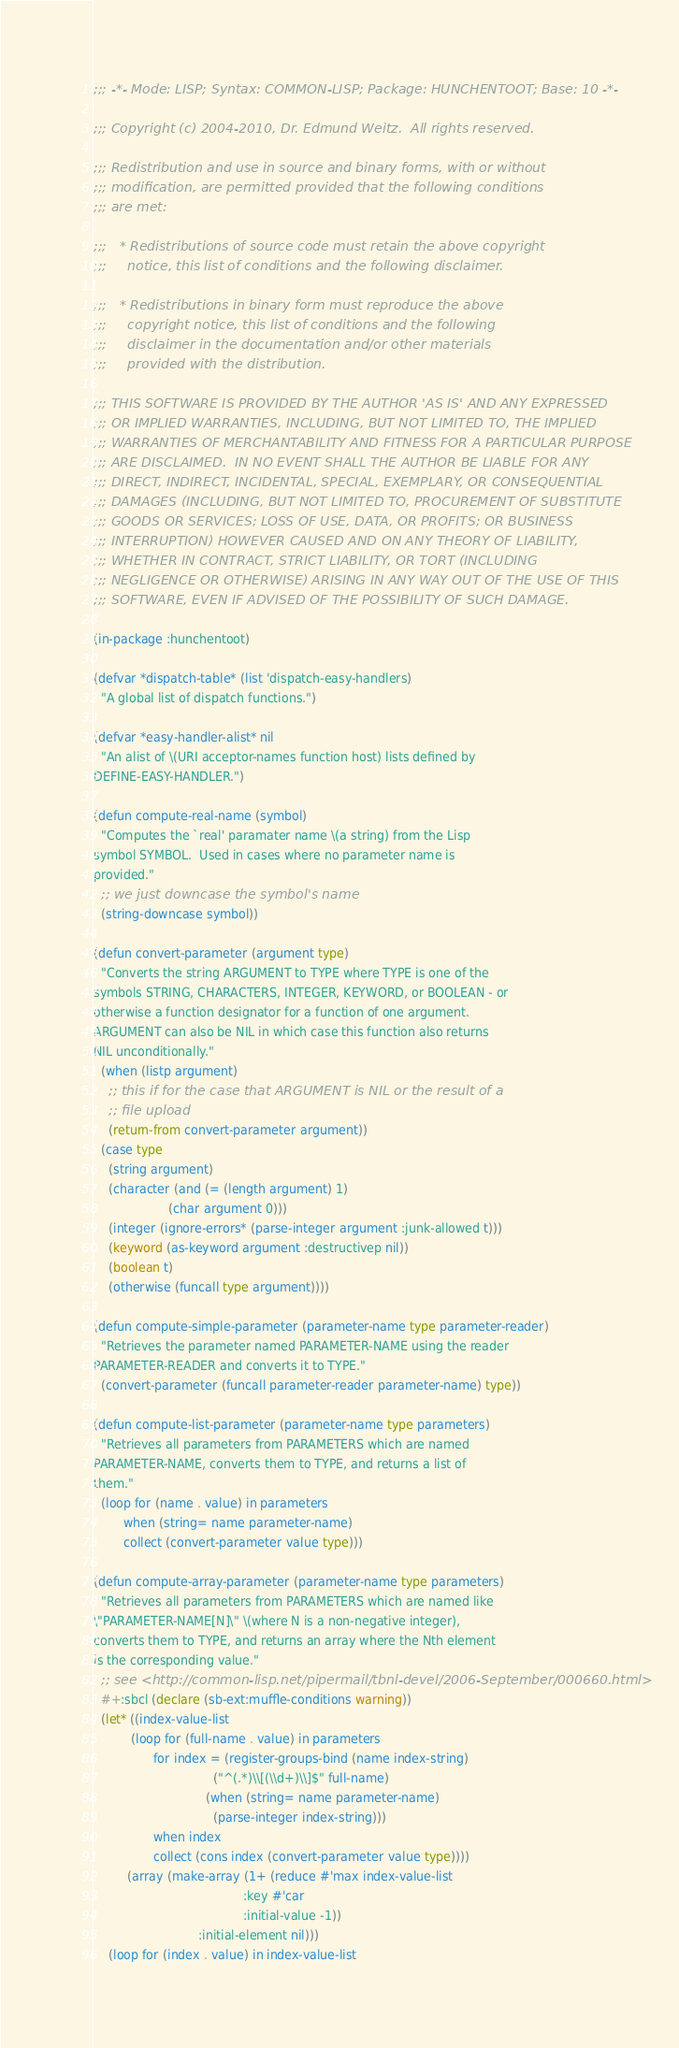Convert code to text. <code><loc_0><loc_0><loc_500><loc_500><_Lisp_>;;; -*- Mode: LISP; Syntax: COMMON-LISP; Package: HUNCHENTOOT; Base: 10 -*-

;;; Copyright (c) 2004-2010, Dr. Edmund Weitz.  All rights reserved.

;;; Redistribution and use in source and binary forms, with or without
;;; modification, are permitted provided that the following conditions
;;; are met:

;;;   * Redistributions of source code must retain the above copyright
;;;     notice, this list of conditions and the following disclaimer.

;;;   * Redistributions in binary form must reproduce the above
;;;     copyright notice, this list of conditions and the following
;;;     disclaimer in the documentation and/or other materials
;;;     provided with the distribution.

;;; THIS SOFTWARE IS PROVIDED BY THE AUTHOR 'AS IS' AND ANY EXPRESSED
;;; OR IMPLIED WARRANTIES, INCLUDING, BUT NOT LIMITED TO, THE IMPLIED
;;; WARRANTIES OF MERCHANTABILITY AND FITNESS FOR A PARTICULAR PURPOSE
;;; ARE DISCLAIMED.  IN NO EVENT SHALL THE AUTHOR BE LIABLE FOR ANY
;;; DIRECT, INDIRECT, INCIDENTAL, SPECIAL, EXEMPLARY, OR CONSEQUENTIAL
;;; DAMAGES (INCLUDING, BUT NOT LIMITED TO, PROCUREMENT OF SUBSTITUTE
;;; GOODS OR SERVICES; LOSS OF USE, DATA, OR PROFITS; OR BUSINESS
;;; INTERRUPTION) HOWEVER CAUSED AND ON ANY THEORY OF LIABILITY,
;;; WHETHER IN CONTRACT, STRICT LIABILITY, OR TORT (INCLUDING
;;; NEGLIGENCE OR OTHERWISE) ARISING IN ANY WAY OUT OF THE USE OF THIS
;;; SOFTWARE, EVEN IF ADVISED OF THE POSSIBILITY OF SUCH DAMAGE.

(in-package :hunchentoot)

(defvar *dispatch-table* (list 'dispatch-easy-handlers)
  "A global list of dispatch functions.")

(defvar *easy-handler-alist* nil
  "An alist of \(URI acceptor-names function host) lists defined by
DEFINE-EASY-HANDLER.")

(defun compute-real-name (symbol)
  "Computes the `real' paramater name \(a string) from the Lisp
symbol SYMBOL.  Used in cases where no parameter name is
provided."
  ;; we just downcase the symbol's name
  (string-downcase symbol))

(defun convert-parameter (argument type)
  "Converts the string ARGUMENT to TYPE where TYPE is one of the
symbols STRING, CHARACTERS, INTEGER, KEYWORD, or BOOLEAN - or
otherwise a function designator for a function of one argument.
ARGUMENT can also be NIL in which case this function also returns
NIL unconditionally."
  (when (listp argument)
    ;; this if for the case that ARGUMENT is NIL or the result of a
    ;; file upload
    (return-from convert-parameter argument))
  (case type
    (string argument)
    (character (and (= (length argument) 1)
                    (char argument 0)))
    (integer (ignore-errors* (parse-integer argument :junk-allowed t)))
    (keyword (as-keyword argument :destructivep nil))
    (boolean t)
    (otherwise (funcall type argument))))

(defun compute-simple-parameter (parameter-name type parameter-reader)
  "Retrieves the parameter named PARAMETER-NAME using the reader
PARAMETER-READER and converts it to TYPE."
  (convert-parameter (funcall parameter-reader parameter-name) type))

(defun compute-list-parameter (parameter-name type parameters)
  "Retrieves all parameters from PARAMETERS which are named
PARAMETER-NAME, converts them to TYPE, and returns a list of
them."
  (loop for (name . value) in parameters
        when (string= name parameter-name)
        collect (convert-parameter value type)))

(defun compute-array-parameter (parameter-name type parameters)
  "Retrieves all parameters from PARAMETERS which are named like
\"PARAMETER-NAME[N]\" \(where N is a non-negative integer),
converts them to TYPE, and returns an array where the Nth element
is the corresponding value."
  ;; see <http://common-lisp.net/pipermail/tbnl-devel/2006-September/000660.html>
  #+:sbcl (declare (sb-ext:muffle-conditions warning))
  (let* ((index-value-list
          (loop for (full-name . value) in parameters
                for index = (register-groups-bind (name index-string)
                                ("^(.*)\\[(\\d+)\\]$" full-name)
                              (when (string= name parameter-name)
                                (parse-integer index-string)))
                when index
                collect (cons index (convert-parameter value type))))
         (array (make-array (1+ (reduce #'max index-value-list
                                        :key #'car
                                        :initial-value -1))
                            :initial-element nil)))
    (loop for (index . value) in index-value-list</code> 